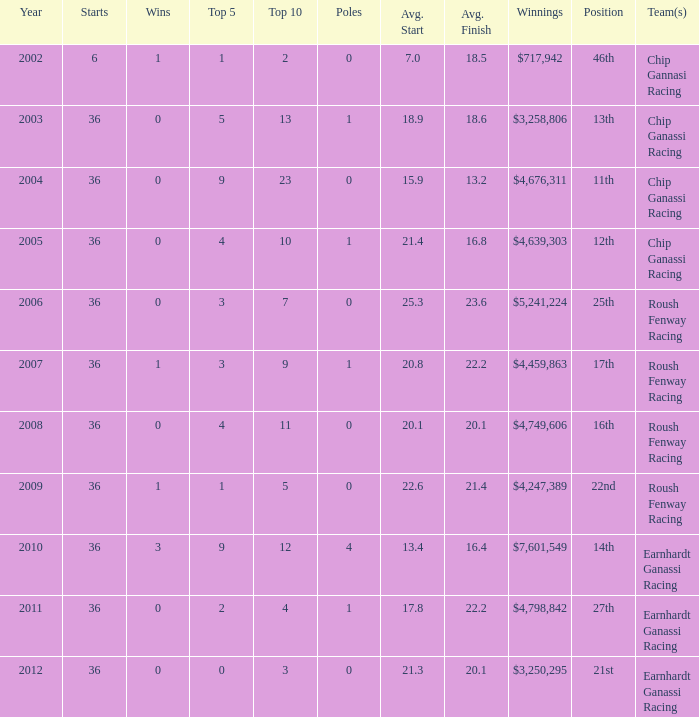Name the starts when position is 16th 36.0. 